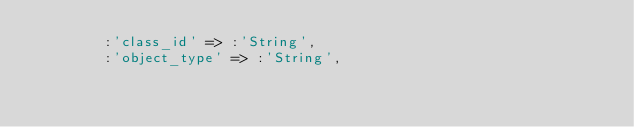<code> <loc_0><loc_0><loc_500><loc_500><_Ruby_>        :'class_id' => :'String',
        :'object_type' => :'String',</code> 